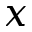Convert formula to latex. <formula><loc_0><loc_0><loc_500><loc_500>x</formula> 